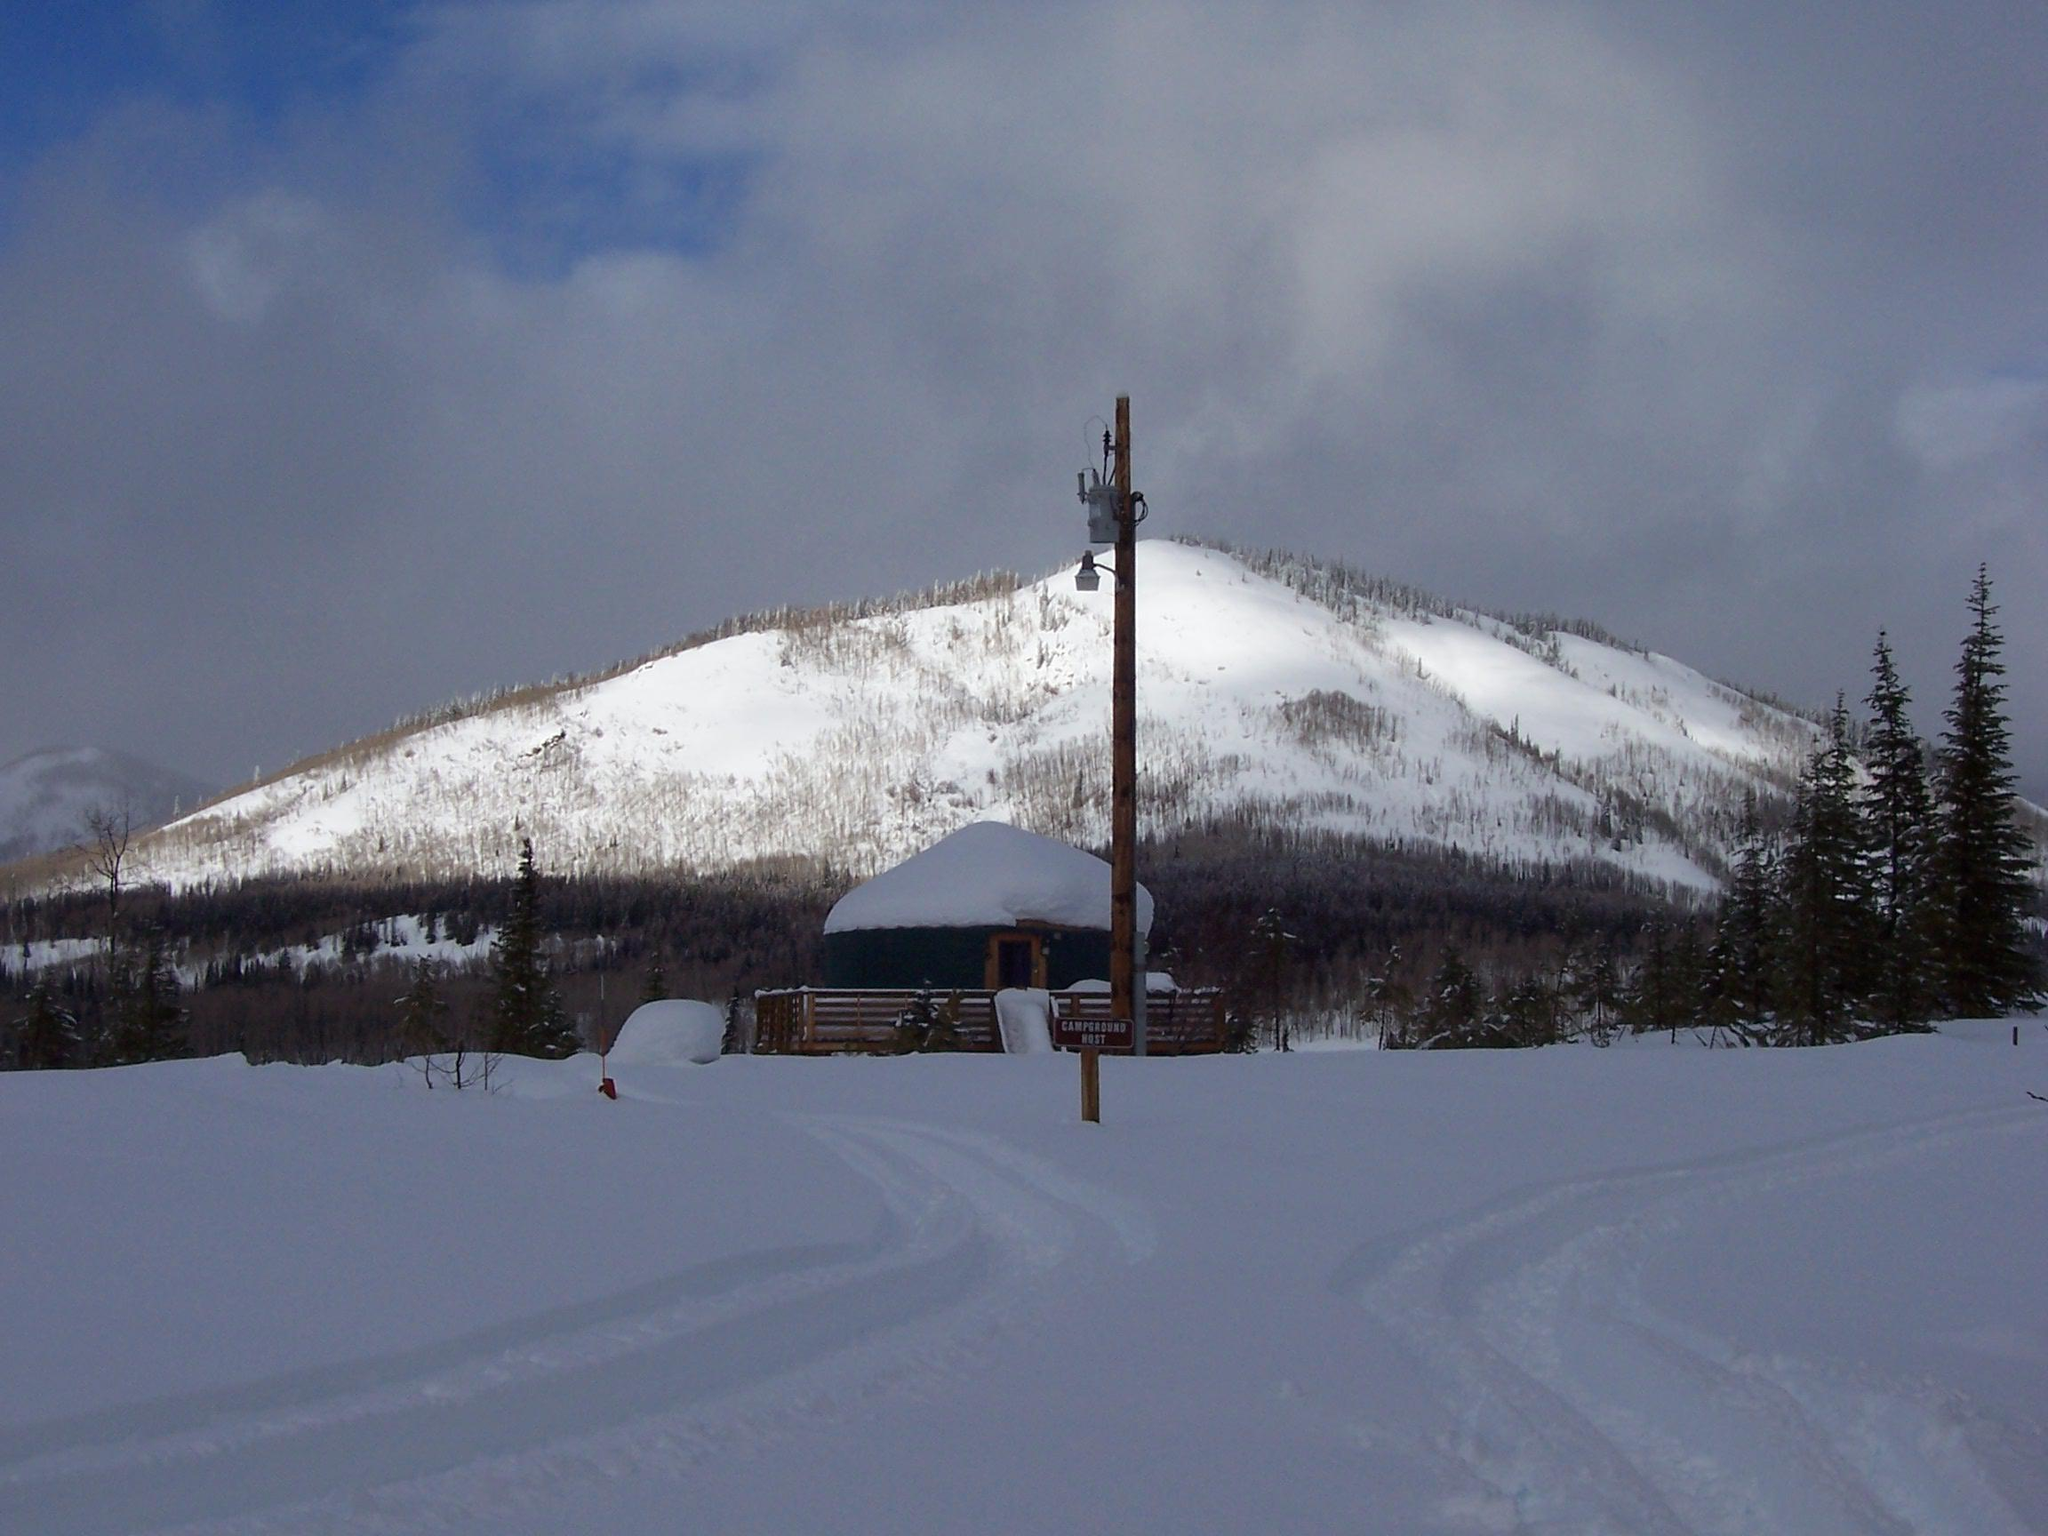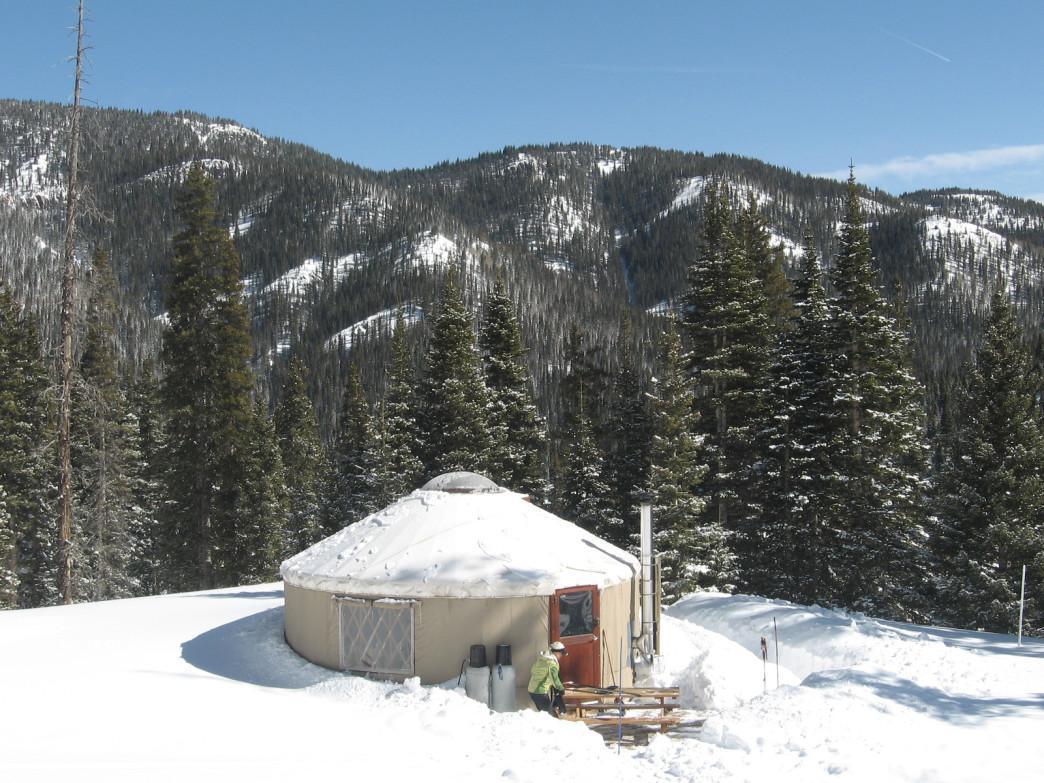The first image is the image on the left, the second image is the image on the right. Given the left and right images, does the statement "there is no fence around the yurt in the image on the right" hold true? Answer yes or no. Yes. The first image is the image on the left, the second image is the image on the right. Examine the images to the left and right. Is the description "Two green round houses have white roofs and sit on flat wooden platforms." accurate? Answer yes or no. No. 